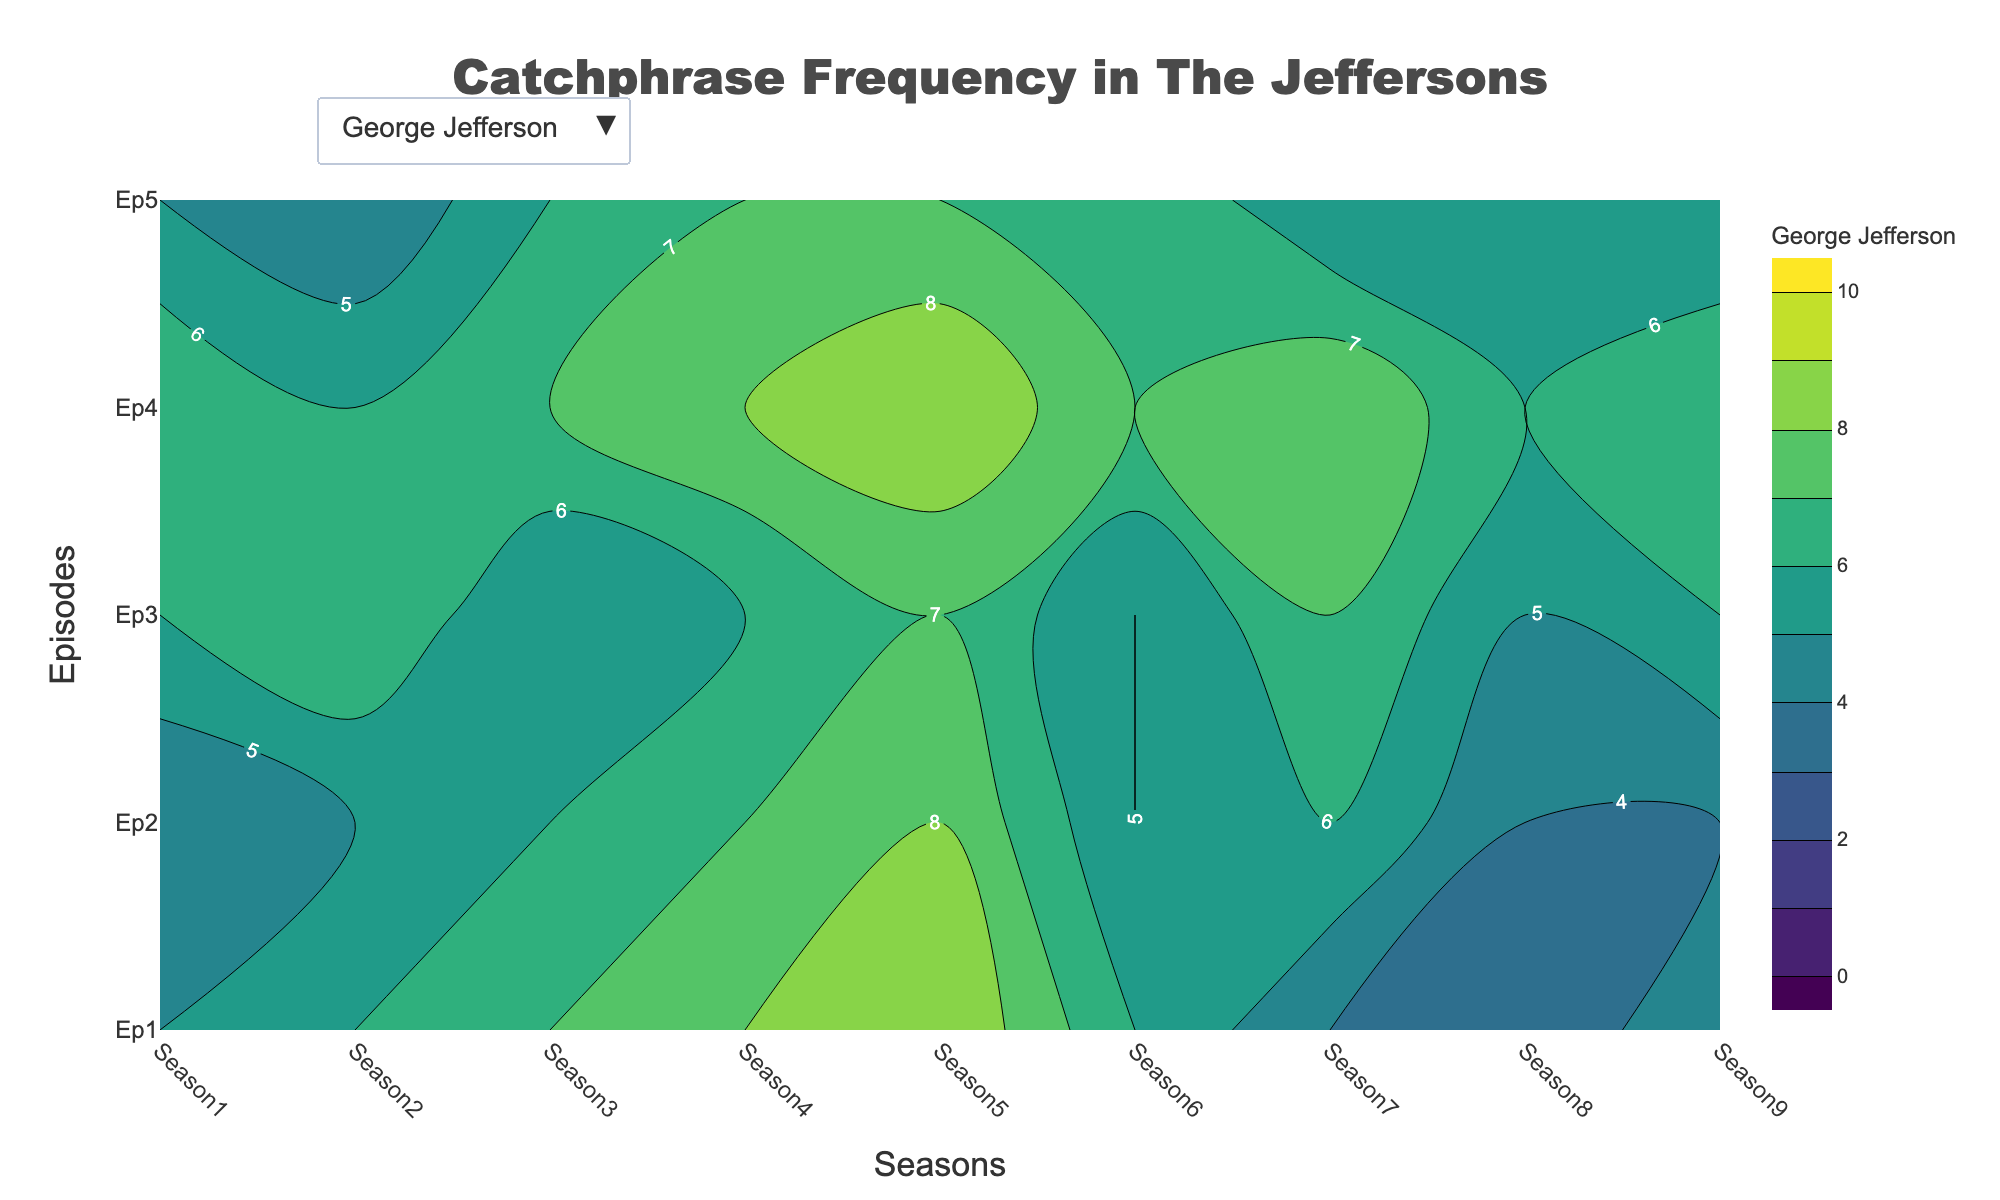What is the title of the plot? The title is usually found at the top of the plot. It provides an overview of what the figure is about.
Answer: "Catchphrase Frequency in The Jeffersons" Which character shows the catchphrase frequency by default when the plot is first shown? The figure's data for the first character is visible by default.
Answer: George Jefferson In Season 4, did George Jefferson use catchphrases more frequently in Episode 1 or Episode 2? Compare the contour values for Season 4 at Episode 1 and Episode 2 for George Jefferson on the plot.
Answer: Episode 1 Which season had the highest catchphrase frequency for Florence Johnston across all episodes? By examining the contour lines and their labels for each season, determine the peak for Florence Johnston's usage.
Answer: Season 4 Compare the overall trend of catchphrase usage from Season 1 to Season 9 for Louise Jefferson. Does the frequency increase, decrease, or stay the same? Look at the contour labels across the timeline (Season 1-9) for Louise Jefferson and observe whether the numbers are generally rising, falling, or stable.
Answer: Mostly increases What is the average catchphrase frequency for Tom Willis in Episode 3 across all seasons? Sum up the contour values for Tom Willis in Episode 3 across all seasons and then divide by the number of seasons.
Answer: (4 + 5 + 3 + 4 + 5 + 4 + 4 + 4 + 4) / 9 = 4.11 For Helen Willis, in which season does the catchphrase usage see the biggest difference between Episode 1 and Episode 5? For each season, calculate the absolute difference between the values for Episode 1 and Episode 5, and find the maximum difference.
Answer: Season 9 Is there any season where George Jefferson consistently used more or fewer catchphrases than the other characters? Compare the contour lines labeled for George Jefferson in each season with those of other characters.
Answer: No consistent season In Season 7, who has the highest frequency of catchphrase usage in Episode 4? Identify and compare the contour values for Episode 4 in Season 7 among all characters.
Answer: George Jefferson 